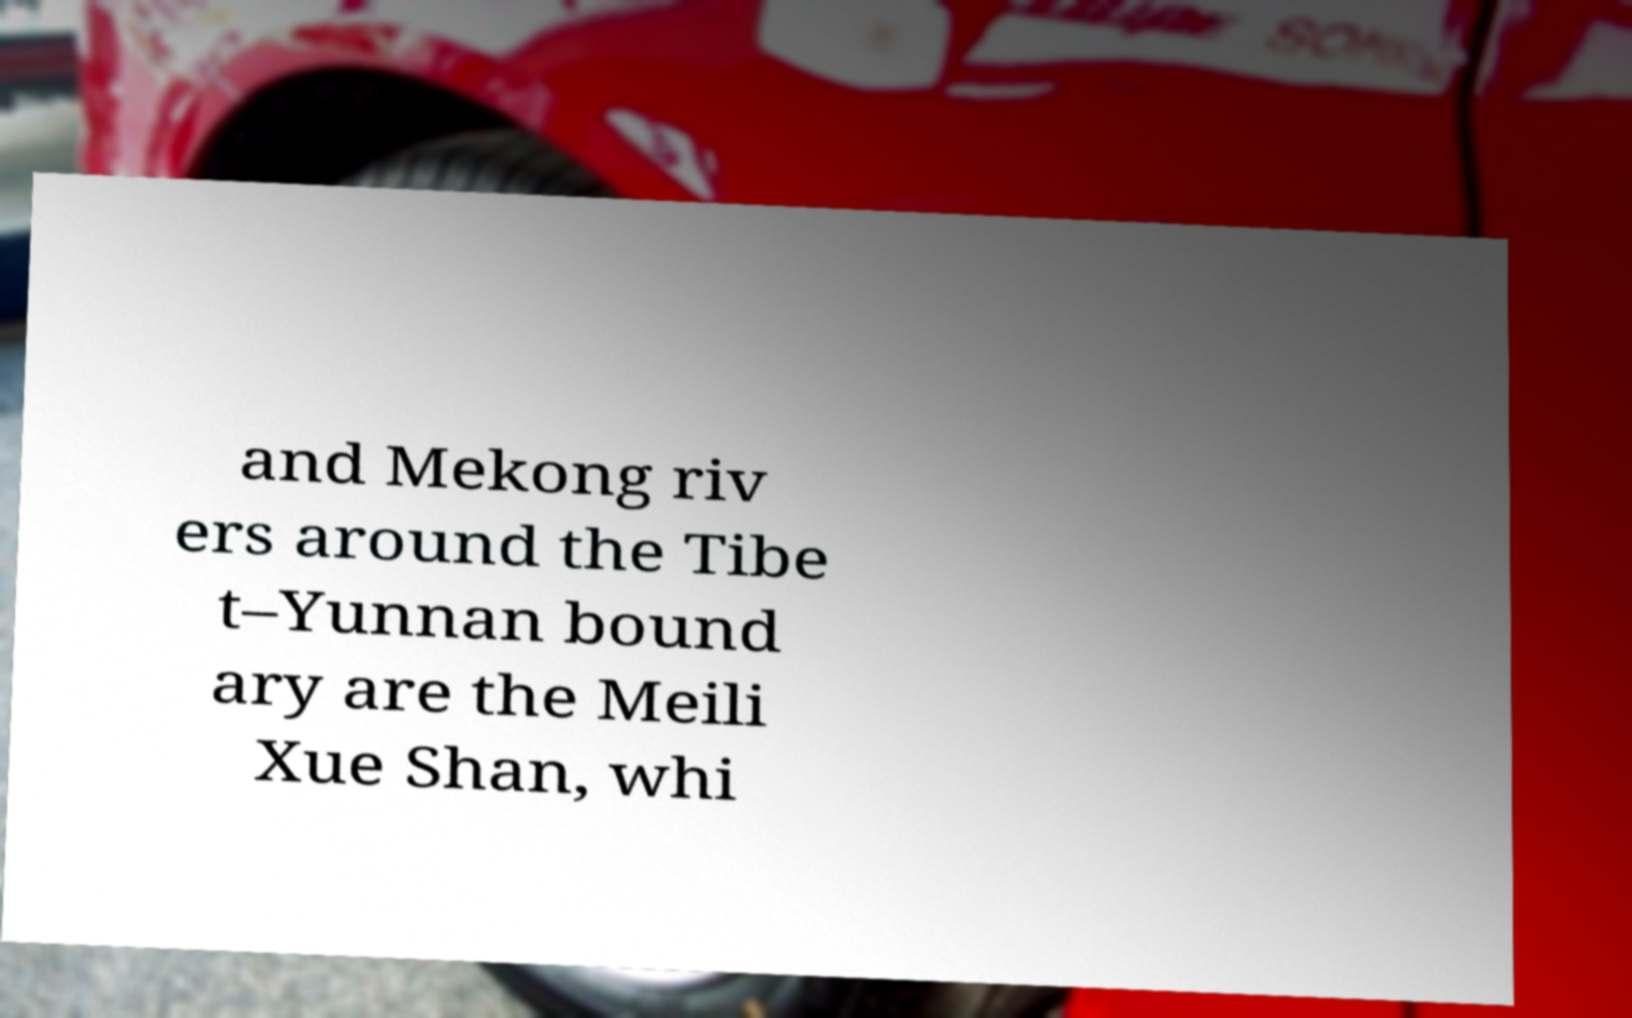There's text embedded in this image that I need extracted. Can you transcribe it verbatim? and Mekong riv ers around the Tibe t–Yunnan bound ary are the Meili Xue Shan, whi 